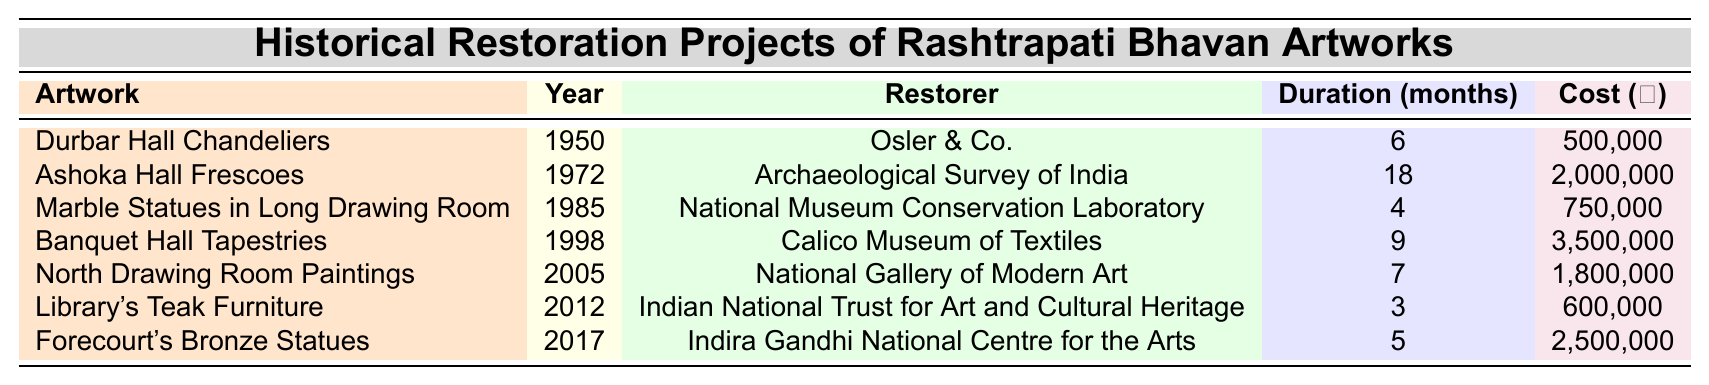What year did the restoration of the Ashoka Hall Frescoes take place? The table lists the restoration projects along with their years. By looking at the row for Ashoka Hall Frescoes, the year is clearly noted as 1972.
Answer: 1972 Who restored the Durbar Hall Chandeliers? The table contains a column for the restorer of each artwork. For the Durbar Hall Chandeliers, the restorer is listed as Osler & Co.
Answer: Osler & Co What was the duration of the restoration for the North Drawing Room Paintings? The table shows the duration in months for each project. For the North Drawing Room Paintings, it shows a duration of 7 months.
Answer: 7 months What is the total cost of restoring the Banquet Hall Tapestries and the Library's Teak Furniture? First, locate the costs for each artwork: the Banquet Hall Tapestries cost ₹3,500,000, and the Library's Teak Furniture cost ₹600,000. Adding these together gives ₹3,500,000 + ₹600,000 = ₹4,100,000.
Answer: ₹4,100,000 How many months did the restoration of the Ashoka Hall Frescoes take? By referring to the row for Ashoka Hall Frescoes, we can see that it took 18 months for restoration.
Answer: 18 months Was the restoration of the Marble Statues in Long Drawing Room more expensive than the restoration of the Library's Teak Furniture? The cost for the Marble Statues is ₹750,000, while the Library's Teak Furniture cost ₹600,000. Since ₹750,000 is greater than ₹600,000, it confirms this is true.
Answer: Yes What was the average cost of all the restoration projects? To find the average cost, calculate the total cost from each project: ₹500,000 + ₹2,000,000 + ₹750,000 + ₹3,500,000 + ₹1,800,000 + ₹600,000 + ₹2,500,000 = ₹11,150,000. There are 7 projects, so the average cost is ₹11,150,000 / 7 = approximately ₹1,592,857.14.
Answer: Approximately ₹1,592,857 In which year did the restoration of the Forecourt's Bronze Statues occur? The row for Forecourt's Bronze Statues indicates the year of restoration as 2017.
Answer: 2017 Which restoration project had the longest duration? By examining the duration column, the Ashoka Hall Frescoes has the longest duration at 18 months, making it the longest restoration project.
Answer: Ashoka Hall Frescoes Is the cost of restoring the Banquet Hall Tapestries the highest among all projects? The cost for the Banquet Hall Tapestries is ₹3,500,000. Comparing this to the other projects, no other project exceeds this cost, confirming it as the highest.
Answer: Yes 